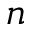Convert formula to latex. <formula><loc_0><loc_0><loc_500><loc_500>n</formula> 